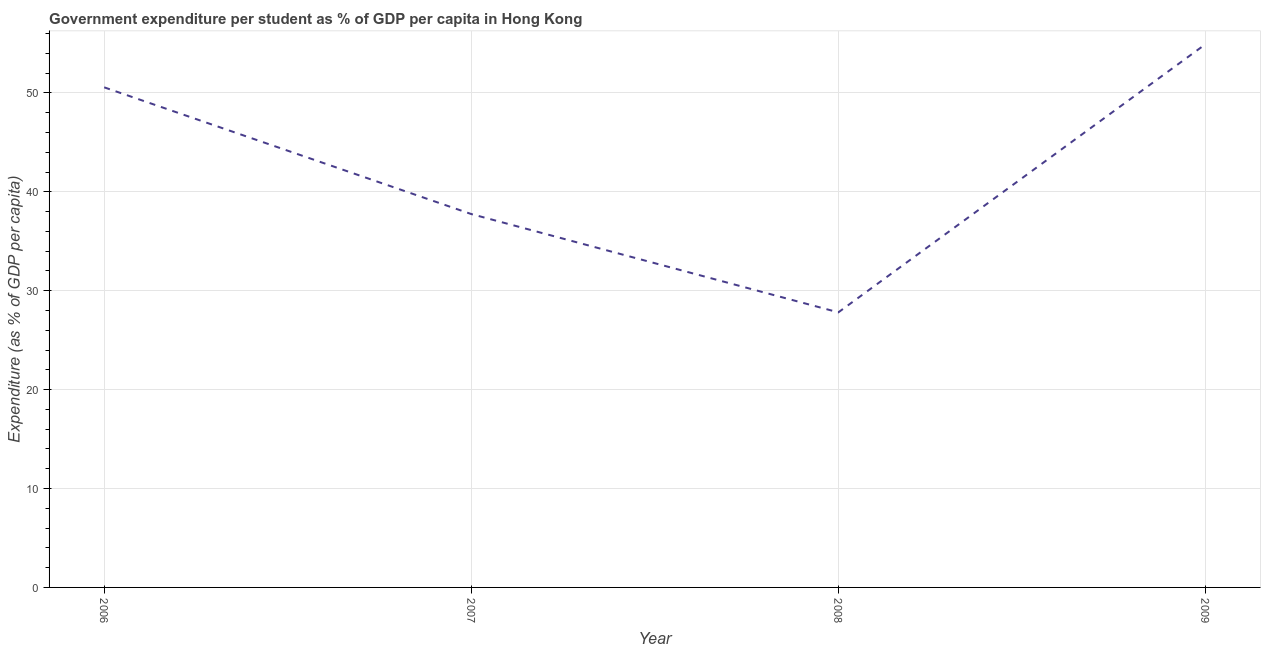What is the government expenditure per student in 2009?
Your answer should be very brief. 54.92. Across all years, what is the maximum government expenditure per student?
Your answer should be compact. 54.92. Across all years, what is the minimum government expenditure per student?
Your answer should be compact. 27.81. What is the sum of the government expenditure per student?
Make the answer very short. 171.05. What is the difference between the government expenditure per student in 2007 and 2008?
Keep it short and to the point. 9.94. What is the average government expenditure per student per year?
Ensure brevity in your answer.  42.76. What is the median government expenditure per student?
Make the answer very short. 44.16. What is the ratio of the government expenditure per student in 2006 to that in 2008?
Ensure brevity in your answer.  1.82. Is the government expenditure per student in 2006 less than that in 2007?
Provide a succinct answer. No. What is the difference between the highest and the second highest government expenditure per student?
Give a very brief answer. 4.36. What is the difference between the highest and the lowest government expenditure per student?
Keep it short and to the point. 27.11. In how many years, is the government expenditure per student greater than the average government expenditure per student taken over all years?
Give a very brief answer. 2. How many lines are there?
Ensure brevity in your answer.  1. What is the difference between two consecutive major ticks on the Y-axis?
Ensure brevity in your answer.  10. Does the graph contain grids?
Give a very brief answer. Yes. What is the title of the graph?
Offer a terse response. Government expenditure per student as % of GDP per capita in Hong Kong. What is the label or title of the Y-axis?
Make the answer very short. Expenditure (as % of GDP per capita). What is the Expenditure (as % of GDP per capita) in 2006?
Your response must be concise. 50.56. What is the Expenditure (as % of GDP per capita) of 2007?
Offer a very short reply. 37.75. What is the Expenditure (as % of GDP per capita) in 2008?
Your response must be concise. 27.81. What is the Expenditure (as % of GDP per capita) in 2009?
Your response must be concise. 54.92. What is the difference between the Expenditure (as % of GDP per capita) in 2006 and 2007?
Your answer should be compact. 12.81. What is the difference between the Expenditure (as % of GDP per capita) in 2006 and 2008?
Offer a terse response. 22.75. What is the difference between the Expenditure (as % of GDP per capita) in 2006 and 2009?
Keep it short and to the point. -4.36. What is the difference between the Expenditure (as % of GDP per capita) in 2007 and 2008?
Your answer should be very brief. 9.94. What is the difference between the Expenditure (as % of GDP per capita) in 2007 and 2009?
Keep it short and to the point. -17.17. What is the difference between the Expenditure (as % of GDP per capita) in 2008 and 2009?
Keep it short and to the point. -27.11. What is the ratio of the Expenditure (as % of GDP per capita) in 2006 to that in 2007?
Give a very brief answer. 1.34. What is the ratio of the Expenditure (as % of GDP per capita) in 2006 to that in 2008?
Keep it short and to the point. 1.82. What is the ratio of the Expenditure (as % of GDP per capita) in 2006 to that in 2009?
Make the answer very short. 0.92. What is the ratio of the Expenditure (as % of GDP per capita) in 2007 to that in 2008?
Your answer should be compact. 1.36. What is the ratio of the Expenditure (as % of GDP per capita) in 2007 to that in 2009?
Give a very brief answer. 0.69. What is the ratio of the Expenditure (as % of GDP per capita) in 2008 to that in 2009?
Your answer should be compact. 0.51. 